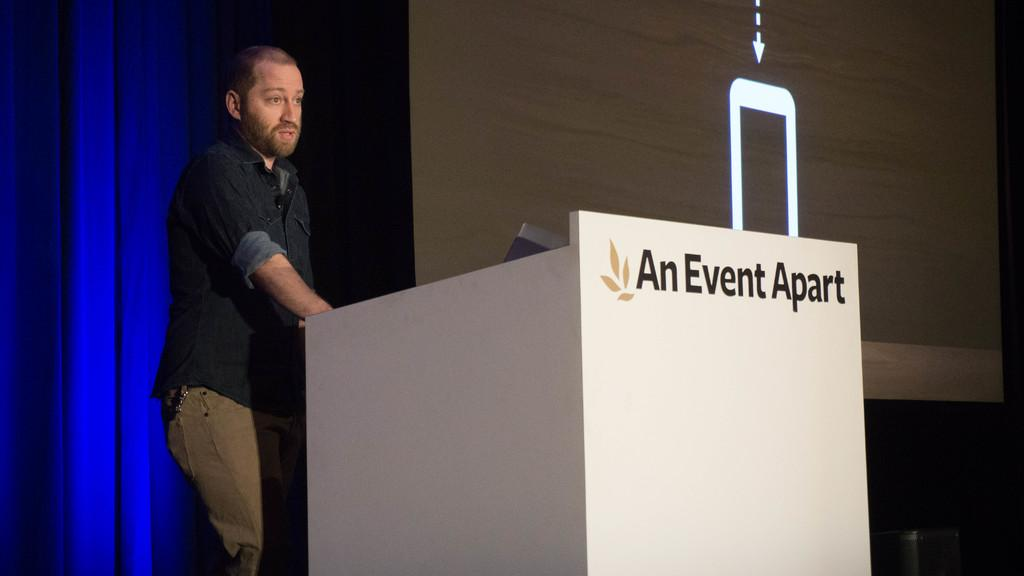What is the man doing in the image? The man is standing near a podium on the left side of the image and talking. What is the man wearing in the image? The man is wearing a shirt and trousers in the image. What can be seen on the right side of the image? There is a projector screen on the right side of the image. How many books does the man have on his fang in the image? There is no mention of a fang or books in the image; the man is talking near a podium and wearing a shirt and trousers. 